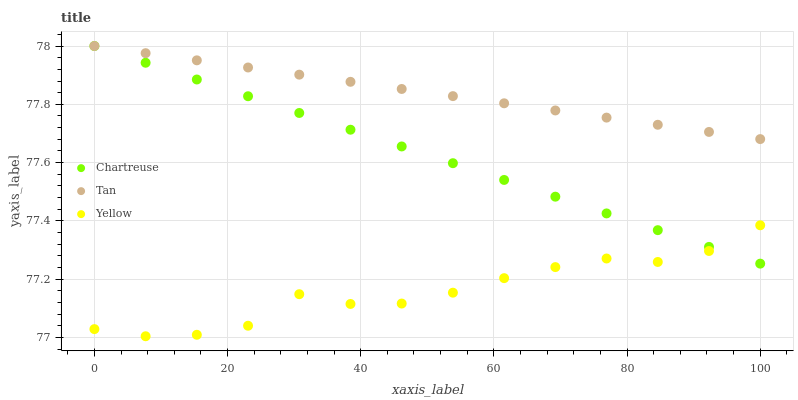Does Yellow have the minimum area under the curve?
Answer yes or no. Yes. Does Tan have the maximum area under the curve?
Answer yes or no. Yes. Does Tan have the minimum area under the curve?
Answer yes or no. No. Does Yellow have the maximum area under the curve?
Answer yes or no. No. Is Tan the smoothest?
Answer yes or no. Yes. Is Yellow the roughest?
Answer yes or no. Yes. Is Yellow the smoothest?
Answer yes or no. No. Is Tan the roughest?
Answer yes or no. No. Does Yellow have the lowest value?
Answer yes or no. Yes. Does Tan have the lowest value?
Answer yes or no. No. Does Tan have the highest value?
Answer yes or no. Yes. Does Yellow have the highest value?
Answer yes or no. No. Is Yellow less than Tan?
Answer yes or no. Yes. Is Tan greater than Yellow?
Answer yes or no. Yes. Does Chartreuse intersect Yellow?
Answer yes or no. Yes. Is Chartreuse less than Yellow?
Answer yes or no. No. Is Chartreuse greater than Yellow?
Answer yes or no. No. Does Yellow intersect Tan?
Answer yes or no. No. 